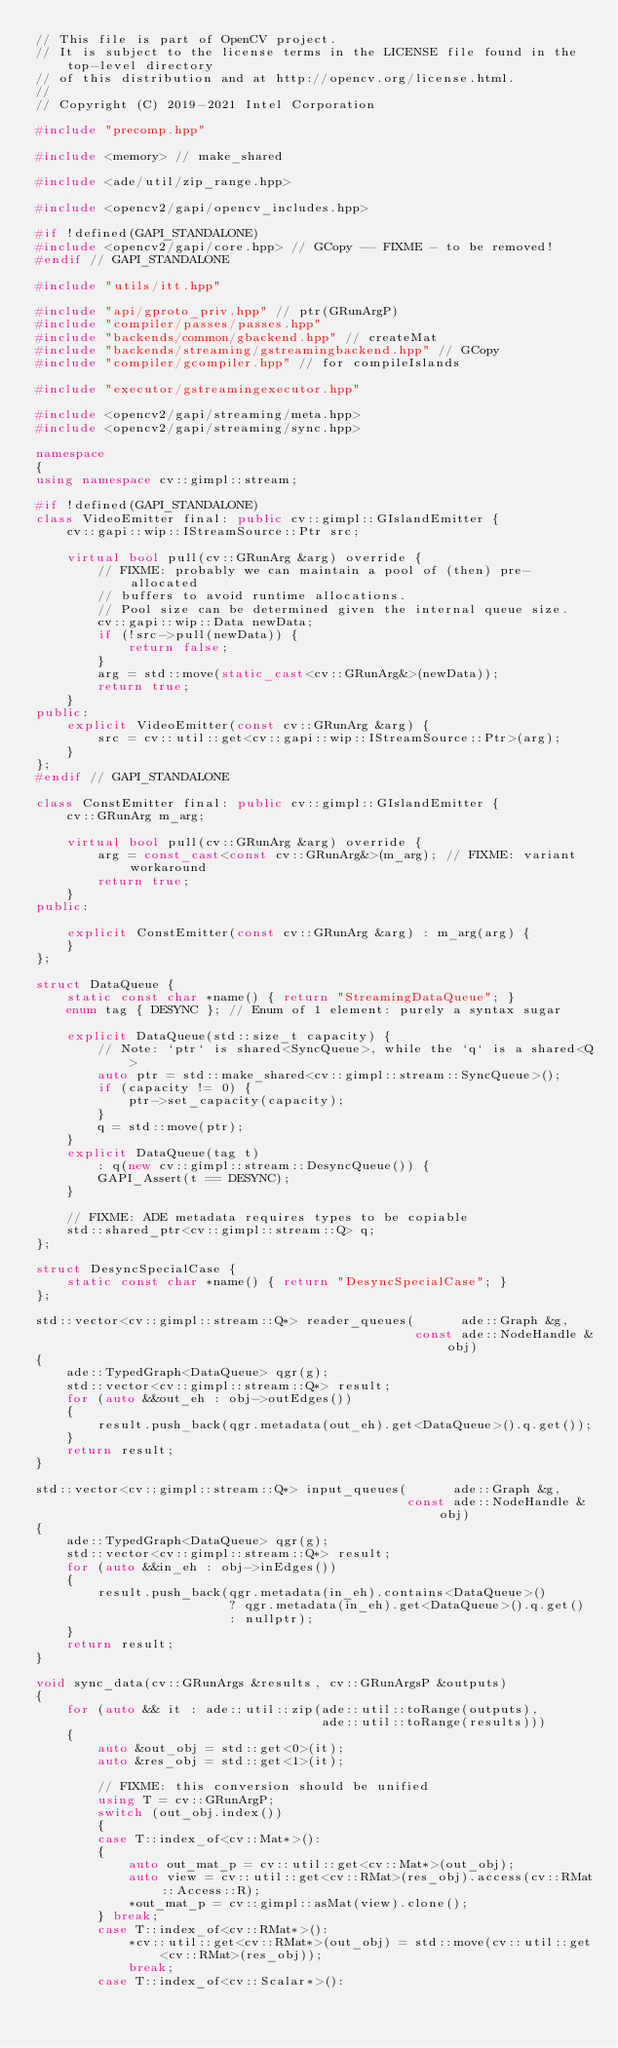Convert code to text. <code><loc_0><loc_0><loc_500><loc_500><_C++_>// This file is part of OpenCV project.
// It is subject to the license terms in the LICENSE file found in the top-level directory
// of this distribution and at http://opencv.org/license.html.
//
// Copyright (C) 2019-2021 Intel Corporation

#include "precomp.hpp"

#include <memory> // make_shared

#include <ade/util/zip_range.hpp>

#include <opencv2/gapi/opencv_includes.hpp>

#if !defined(GAPI_STANDALONE)
#include <opencv2/gapi/core.hpp> // GCopy -- FIXME - to be removed!
#endif // GAPI_STANDALONE

#include "utils/itt.hpp"

#include "api/gproto_priv.hpp" // ptr(GRunArgP)
#include "compiler/passes/passes.hpp"
#include "backends/common/gbackend.hpp" // createMat
#include "backends/streaming/gstreamingbackend.hpp" // GCopy
#include "compiler/gcompiler.hpp" // for compileIslands

#include "executor/gstreamingexecutor.hpp"

#include <opencv2/gapi/streaming/meta.hpp>
#include <opencv2/gapi/streaming/sync.hpp>

namespace
{
using namespace cv::gimpl::stream;

#if !defined(GAPI_STANDALONE)
class VideoEmitter final: public cv::gimpl::GIslandEmitter {
    cv::gapi::wip::IStreamSource::Ptr src;

    virtual bool pull(cv::GRunArg &arg) override {
        // FIXME: probably we can maintain a pool of (then) pre-allocated
        // buffers to avoid runtime allocations.
        // Pool size can be determined given the internal queue size.
        cv::gapi::wip::Data newData;
        if (!src->pull(newData)) {
            return false;
        }
        arg = std::move(static_cast<cv::GRunArg&>(newData));
        return true;
    }
public:
    explicit VideoEmitter(const cv::GRunArg &arg) {
        src = cv::util::get<cv::gapi::wip::IStreamSource::Ptr>(arg);
    }
};
#endif // GAPI_STANDALONE

class ConstEmitter final: public cv::gimpl::GIslandEmitter {
    cv::GRunArg m_arg;

    virtual bool pull(cv::GRunArg &arg) override {
        arg = const_cast<const cv::GRunArg&>(m_arg); // FIXME: variant workaround
        return true;
    }
public:

    explicit ConstEmitter(const cv::GRunArg &arg) : m_arg(arg) {
    }
};

struct DataQueue {
    static const char *name() { return "StreamingDataQueue"; }
    enum tag { DESYNC }; // Enum of 1 element: purely a syntax sugar

    explicit DataQueue(std::size_t capacity) {
        // Note: `ptr` is shared<SyncQueue>, while the `q` is a shared<Q>
        auto ptr = std::make_shared<cv::gimpl::stream::SyncQueue>();
        if (capacity != 0) {
            ptr->set_capacity(capacity);
        }
        q = std::move(ptr);
    }
    explicit DataQueue(tag t)
        : q(new cv::gimpl::stream::DesyncQueue()) {
        GAPI_Assert(t == DESYNC);
    }

    // FIXME: ADE metadata requires types to be copiable
    std::shared_ptr<cv::gimpl::stream::Q> q;
};

struct DesyncSpecialCase {
    static const char *name() { return "DesyncSpecialCase"; }
};

std::vector<cv::gimpl::stream::Q*> reader_queues(      ade::Graph &g,
                                                 const ade::NodeHandle &obj)
{
    ade::TypedGraph<DataQueue> qgr(g);
    std::vector<cv::gimpl::stream::Q*> result;
    for (auto &&out_eh : obj->outEdges())
    {
        result.push_back(qgr.metadata(out_eh).get<DataQueue>().q.get());
    }
    return result;
}

std::vector<cv::gimpl::stream::Q*> input_queues(      ade::Graph &g,
                                                const ade::NodeHandle &obj)
{
    ade::TypedGraph<DataQueue> qgr(g);
    std::vector<cv::gimpl::stream::Q*> result;
    for (auto &&in_eh : obj->inEdges())
    {
        result.push_back(qgr.metadata(in_eh).contains<DataQueue>()
                         ? qgr.metadata(in_eh).get<DataQueue>().q.get()
                         : nullptr);
    }
    return result;
}

void sync_data(cv::GRunArgs &results, cv::GRunArgsP &outputs)
{
    for (auto && it : ade::util::zip(ade::util::toRange(outputs),
                                     ade::util::toRange(results)))
    {
        auto &out_obj = std::get<0>(it);
        auto &res_obj = std::get<1>(it);

        // FIXME: this conversion should be unified
        using T = cv::GRunArgP;
        switch (out_obj.index())
        {
        case T::index_of<cv::Mat*>():
        {
            auto out_mat_p = cv::util::get<cv::Mat*>(out_obj);
            auto view = cv::util::get<cv::RMat>(res_obj).access(cv::RMat::Access::R);
            *out_mat_p = cv::gimpl::asMat(view).clone();
        } break;
        case T::index_of<cv::RMat*>():
            *cv::util::get<cv::RMat*>(out_obj) = std::move(cv::util::get<cv::RMat>(res_obj));
            break;
        case T::index_of<cv::Scalar*>():</code> 